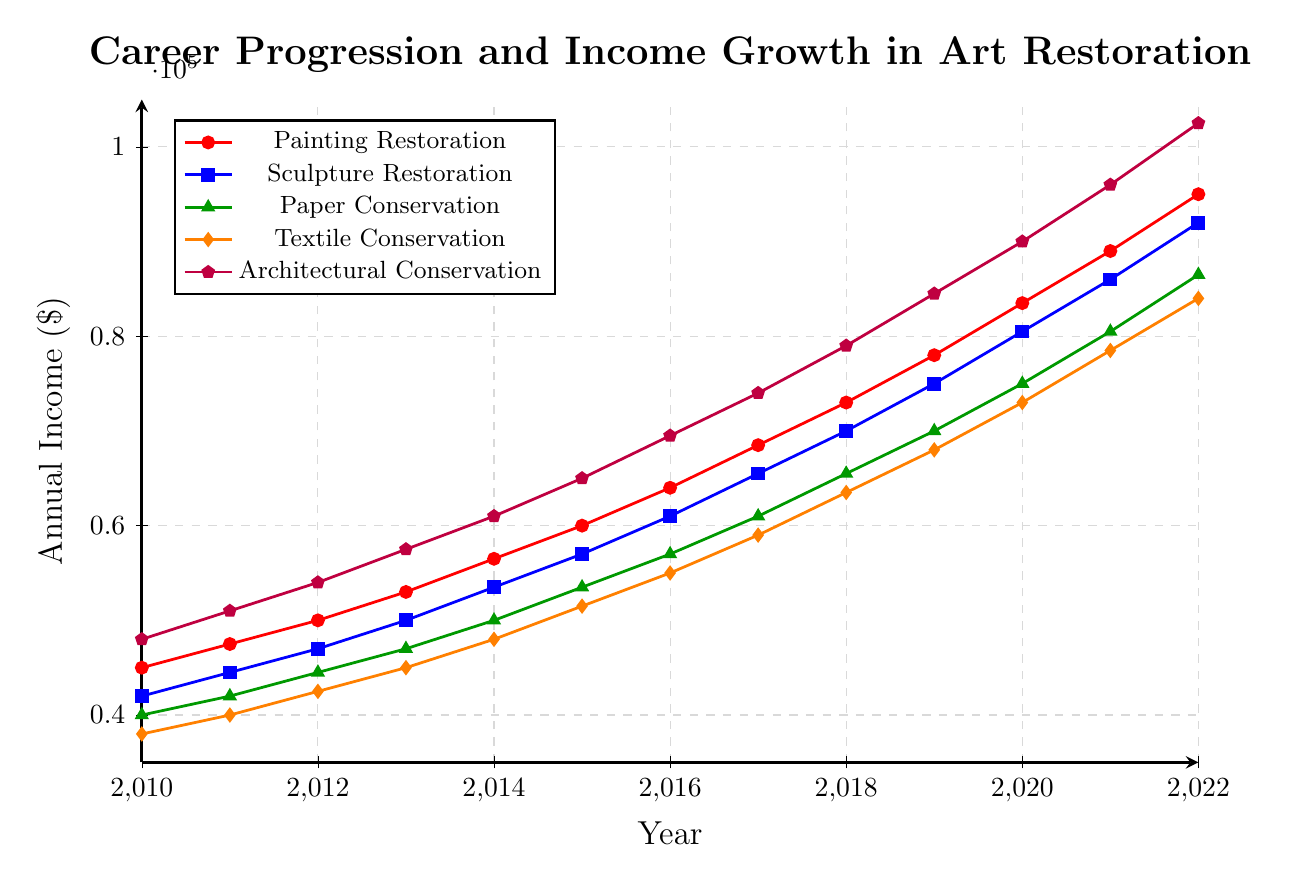How has the annual income for Painting Restoration professionals changed from 2010 to 2022? Look at the red line representing 'Painting Restoration' from 2010 to 2022. The annual income increases from $45,000 in 2010 to $95,000 in 2022. Subtract the initial value from the final value: $95,000 - $45,000 = $50,000.
Answer: Increased by $50,000 Which specialization had the highest income in 2022? Locate the endpoints of the lines for 2022 and identify the highest one. The purple line for 'Architectural Conservation' reaches the highest value of $102,500.
Answer: Architectural Conservation What is the average income of Textile Conservation professionals from 2015 to 2020? Note the annual incomes for each year from 2015 to 2020 in 'Textile Conservation' (orange line): $51,500, $55,000, $59,000, $63,500, $68,000, and $73,000. Sum these values: $51,500 + $55,000 + $59,000 + $63,500 + $68,000 + $73,000 = $370,000. Divide by the number of years (6): $370,000 / 6 = $61,666.67.
Answer: $61,666.67 In which year did Paper Conservation professionals reach an income of $70,000? Follow the green line for 'Paper Conservation' and identify the year when the value hits $70,000. This occurs at 2019.
Answer: 2019 Which specialization saw the greatest percentage increase in income from 2010 to 2022? Calculate the percentage increase for each specialization: \[(\text{2022 Income} - \text{2010 Income}) / \text{2010 Income} \times 100\]
\[(95000 - 45000) / 45000 \times 100 = 111.11\%\]
\[(92000 - 42000) / 42000 \times 100 = 119.05\%\]
\[(86500 - 40000) / 40000 \times 100 = 116.25\%\]
\[(84000 - 38000) / 38000 \times 100 = 121.05\%\]
\[(102500 - 48000) / 48000 \times 100 = 113.54\%\]
Compare results: Textile Conservation had the highest increase of 121.05%.
Answer: Textile Conservation Which two specializations have the closest income values in 2015? Compare the values in 2015 for all specializations: $60,000, $57,000, $53,500, $51,500, $65,000. Paintting and Sculpture Restoration have close incomes of $60,000 and $57,000 respectively. The difference is $3,000.
Answer: Painting Restoration and Sculpture Restoration What was the difference in income between Architectural Conservation and Paper Conservation in 2018? Identify the 2018 values for 'Architectural Conservation' ($79,000) and 'Paper Conservation' ($65,500). Subtract the lower value from the higher value: $79,000 - $65,500 = $13,500.
Answer: $13,500 Which year did Sculpture Restoration professionals' annual income first surpass $70,000? Follow the blue line for 'Sculpture Restoration' and find the first year the value exceeds $70,000. This happens in 2018 with a value of $70,000.
Answer: 2018 Between 2010 and 2022, which specialization shows the most consistent rate of income growth? Examine the slopes of the lines representing each specialization. The red line for 'Painting Restoration' shows a smooth and steady upward trend consistently.
Answer: Painting Restoration 